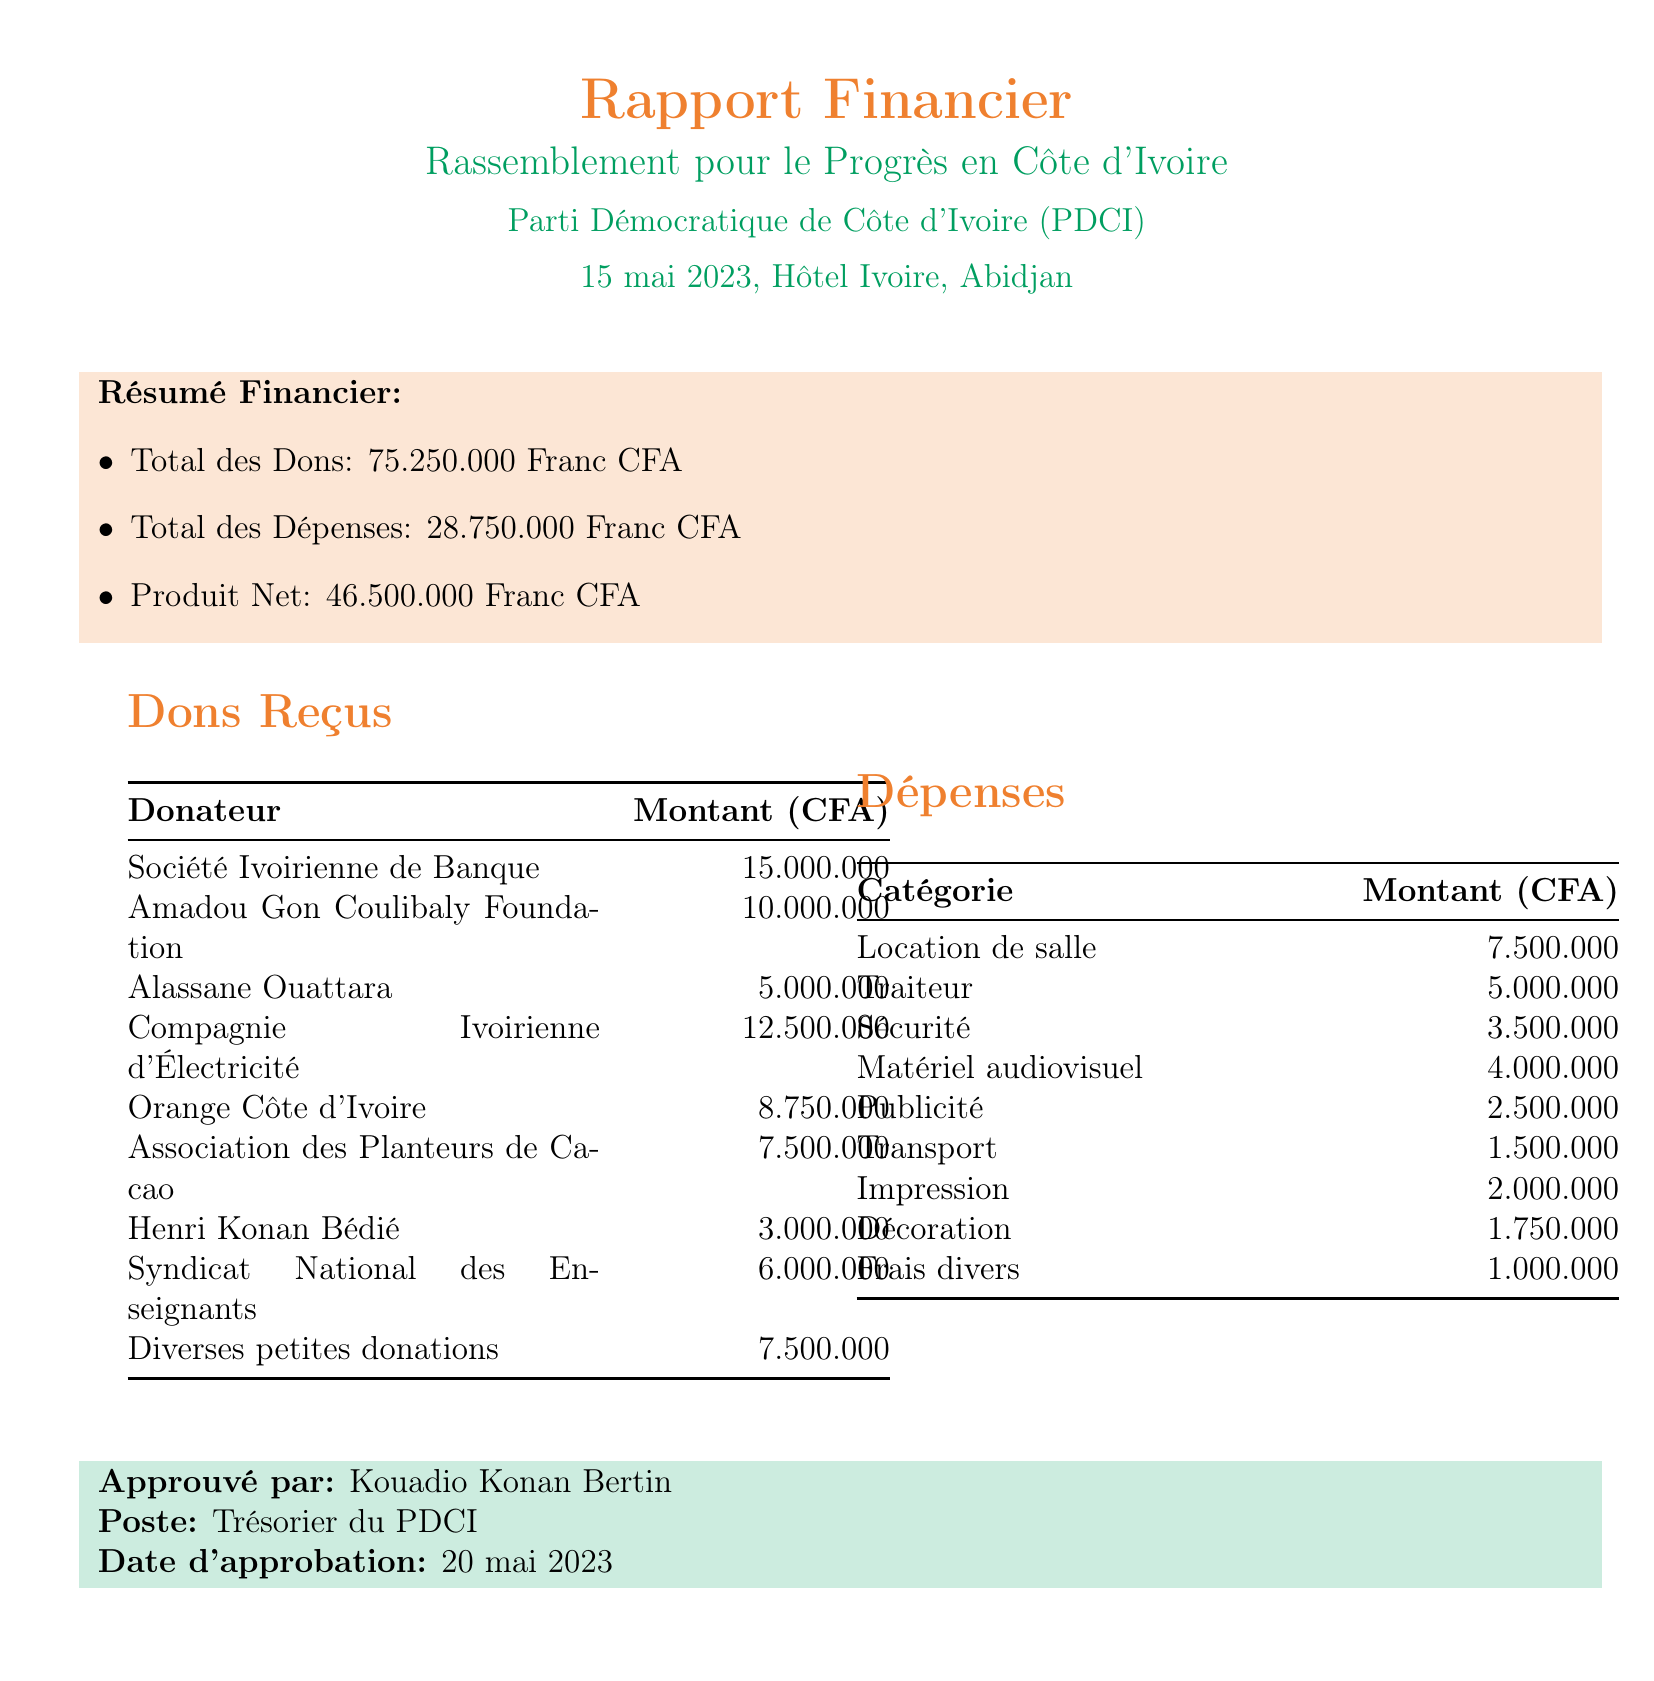What is the name of the event? The event is titled "Rassemblement pour le Progrès en Côte d'Ivoire."
Answer: Rassemblement pour le Progrès en Côte d'Ivoire What is the total amount of donations received? The total donations received for the event is explicitly stated in the document.
Answer: 75250000 Who is the authorized person who approved the financial report? The document lists "Kouadio Konan Bertin" as the person who approved the report.
Answer: Kouadio Konan Bertin What was the date of the fundraising event? The date of the event is mentioned in the document as occurring on 15 mai 2023.
Answer: 2023-05-15 What was the total amount spent on security? The amount spent on the category of security can be found in the expenditure section of the document.
Answer: 3500000 How much did Orange Côte d'Ivoire donate? The document specifies the amount donated by Orange Côte d'Ivoire.
Answer: 8750000 What is the net proceeds from the event? The net proceeds are calculated by subtracting total expenses from total donations, which is provided in the summary.
Answer: 46500000 Which vendor was responsible for the catering services? The document specifies that "Abidjan Catering Services" provided the catering services.
Answer: Abidjan Catering Services How much was spent on advertising? The document lists the expenses incurred for advertising specifically in the expenses section.
Answer: 2500000 